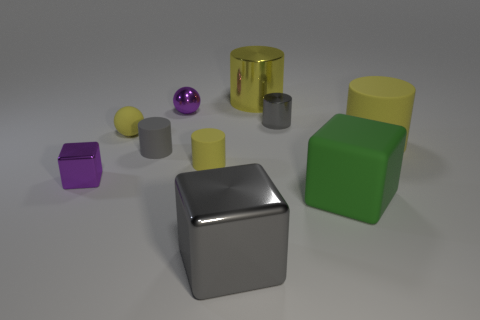What does the arrangement of these objects tell us? The objects appear to be randomly positioned across a flat surface, suggesting they might have been placed there for a visual composition, possibly to study or compare shapes and colors, or to create an artistic arrangement. 